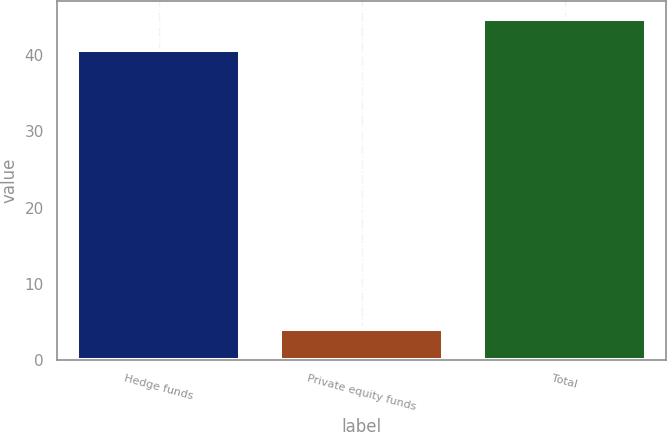<chart> <loc_0><loc_0><loc_500><loc_500><bar_chart><fcel>Hedge funds<fcel>Private equity funds<fcel>Total<nl><fcel>40.7<fcel>4.1<fcel>44.8<nl></chart> 